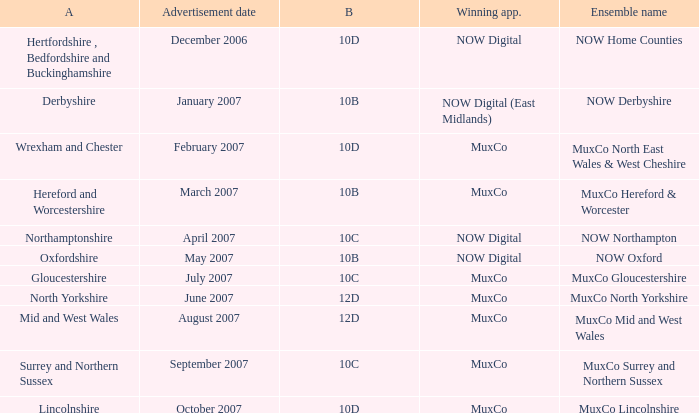Who is the Winning Applicant of Ensemble Name Muxco Lincolnshire in Block 10D? MuxCo. 